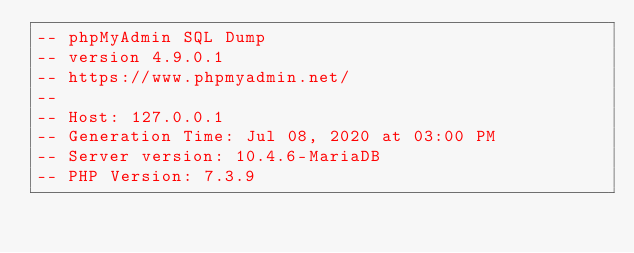<code> <loc_0><loc_0><loc_500><loc_500><_SQL_>-- phpMyAdmin SQL Dump
-- version 4.9.0.1
-- https://www.phpmyadmin.net/
--
-- Host: 127.0.0.1
-- Generation Time: Jul 08, 2020 at 03:00 PM
-- Server version: 10.4.6-MariaDB
-- PHP Version: 7.3.9
</code> 